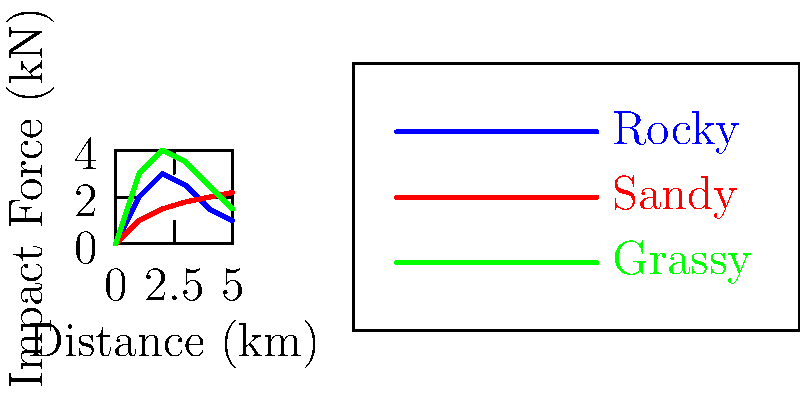Based on the stress distribution graph showing impact forces on different terrain types during off-road tours, which terrain type would likely result in the least wear and tear on tour vehicles, potentially reducing maintenance costs? To determine which terrain type would result in the least wear and tear on tour vehicles, we need to analyze the impact forces shown in the graph for each terrain type:

1. Rocky terrain (blue line):
   - Shows high initial impact forces, peaking at around 3 kN
   - Experiences significant fluctuations in force throughout the distance

2. Sandy terrain (red line):
   - Demonstrates the lowest overall impact forces
   - Maintains a relatively consistent force level, gradually increasing from 1 kN to 2.2 kN

3. Grassy terrain (green line):
   - Exhibits the highest peak impact force, reaching about 4 kN
   - Shows large variations in force over the distance

Step-by-step analysis:
1. Compare peak forces: Sandy < Rocky < Grassy
2. Assess force consistency: Sandy is most consistent, Rocky and Grassy show large variations
3. Evaluate overall force levels: Sandy maintains the lowest forces throughout

Lower impact forces and more consistent stress distribution generally lead to less wear and tear on vehicles. Based on this analysis, sandy terrain would likely result in the least wear and tear on tour vehicles, potentially reducing maintenance costs.
Answer: Sandy terrain 